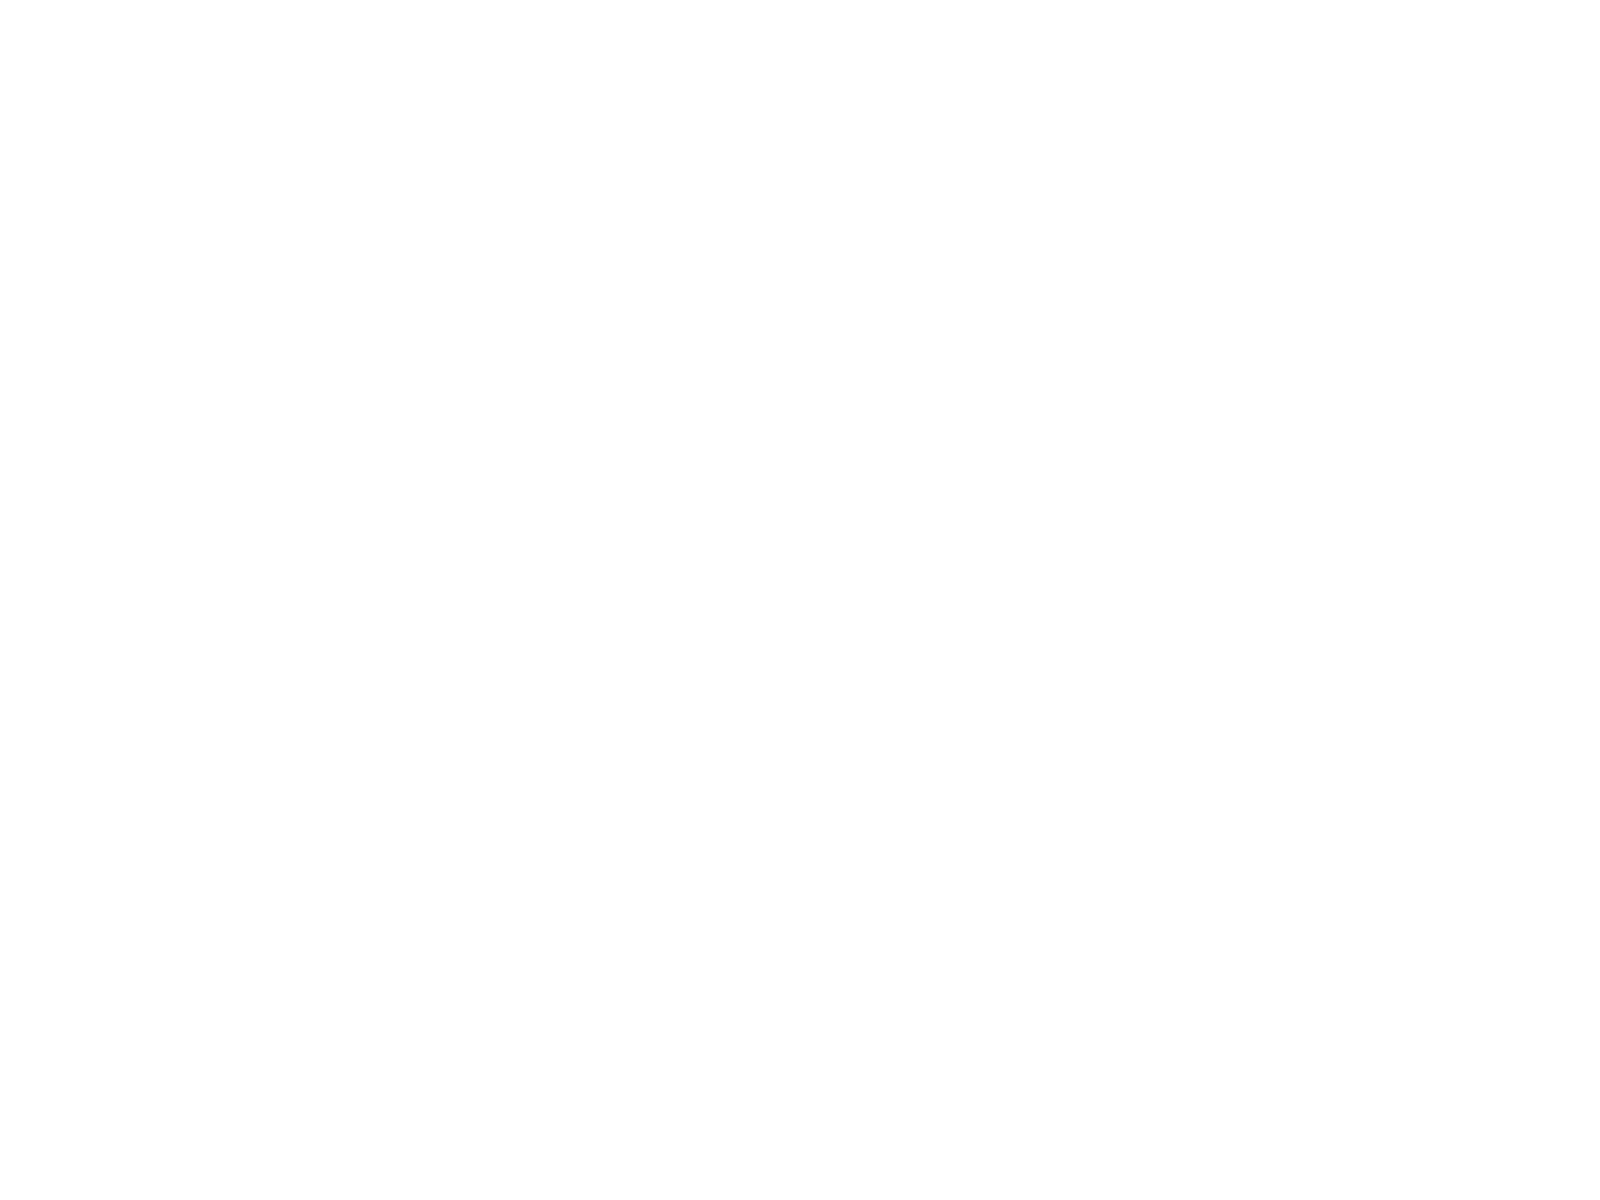<chart> <loc_0><loc_0><loc_500><loc_500><pie_chart><fcel>Completed technologies<fcel>Customer relationships<fcel>Non-compete agreements<fcel>Trademarks and trade names<fcel>Total<nl><fcel>15.39%<fcel>30.82%<fcel>5.18%<fcel>0.4%<fcel>48.21%<nl></chart> 